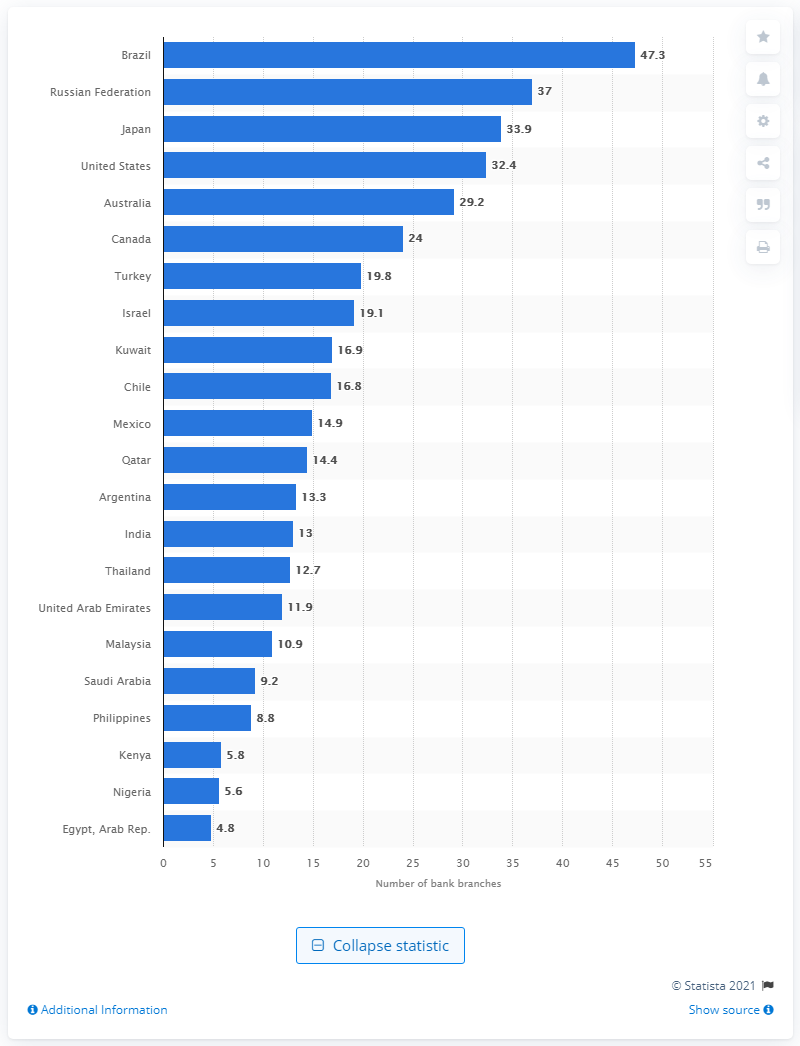List a handful of essential elements in this visual. In 2014, there were 33.9 commercial bank branches in Japan. 